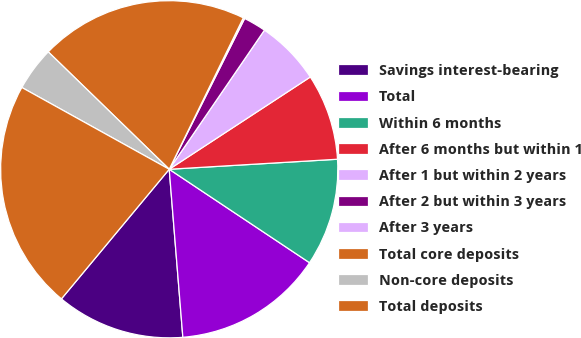Convert chart to OTSL. <chart><loc_0><loc_0><loc_500><loc_500><pie_chart><fcel>Savings interest-bearing<fcel>Total<fcel>Within 6 months<fcel>After 6 months but within 1<fcel>After 1 but within 2 years<fcel>After 2 but within 3 years<fcel>After 3 years<fcel>Total core deposits<fcel>Non-core deposits<fcel>Total deposits<nl><fcel>12.33%<fcel>14.36%<fcel>10.3%<fcel>8.27%<fcel>6.23%<fcel>2.17%<fcel>0.14%<fcel>19.98%<fcel>4.2%<fcel>22.02%<nl></chart> 